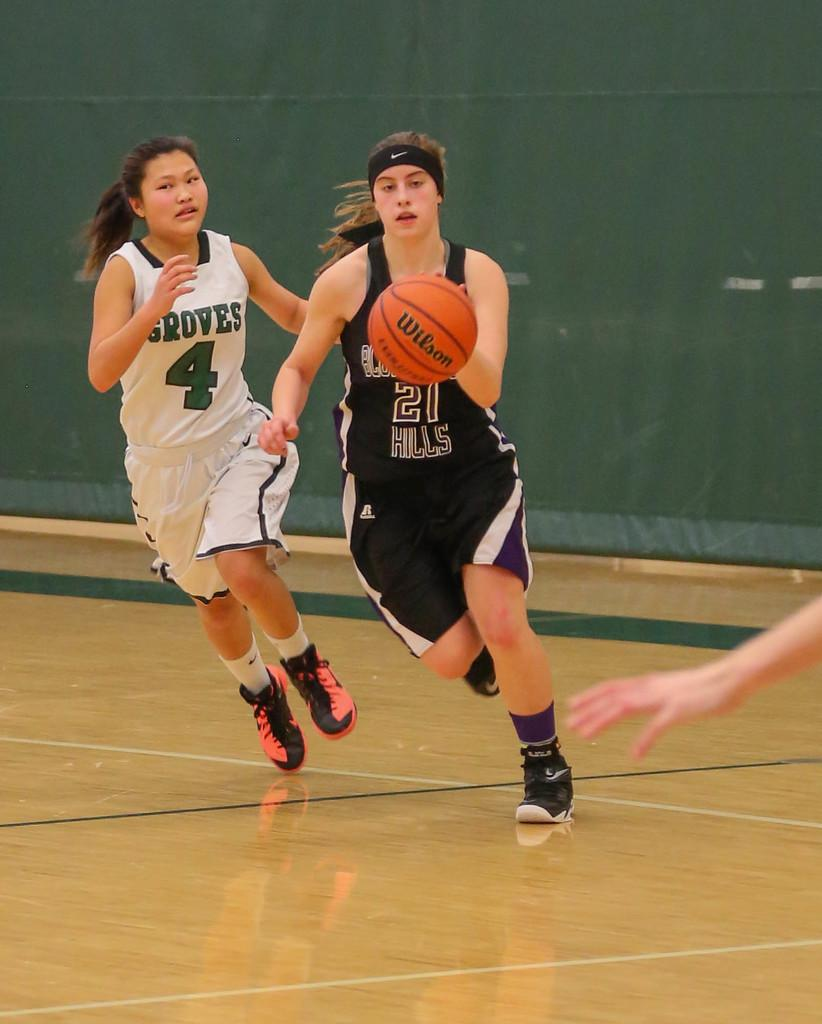Provide a one-sentence caption for the provided image. Two basketball players, one from Groves and one from Hills. 